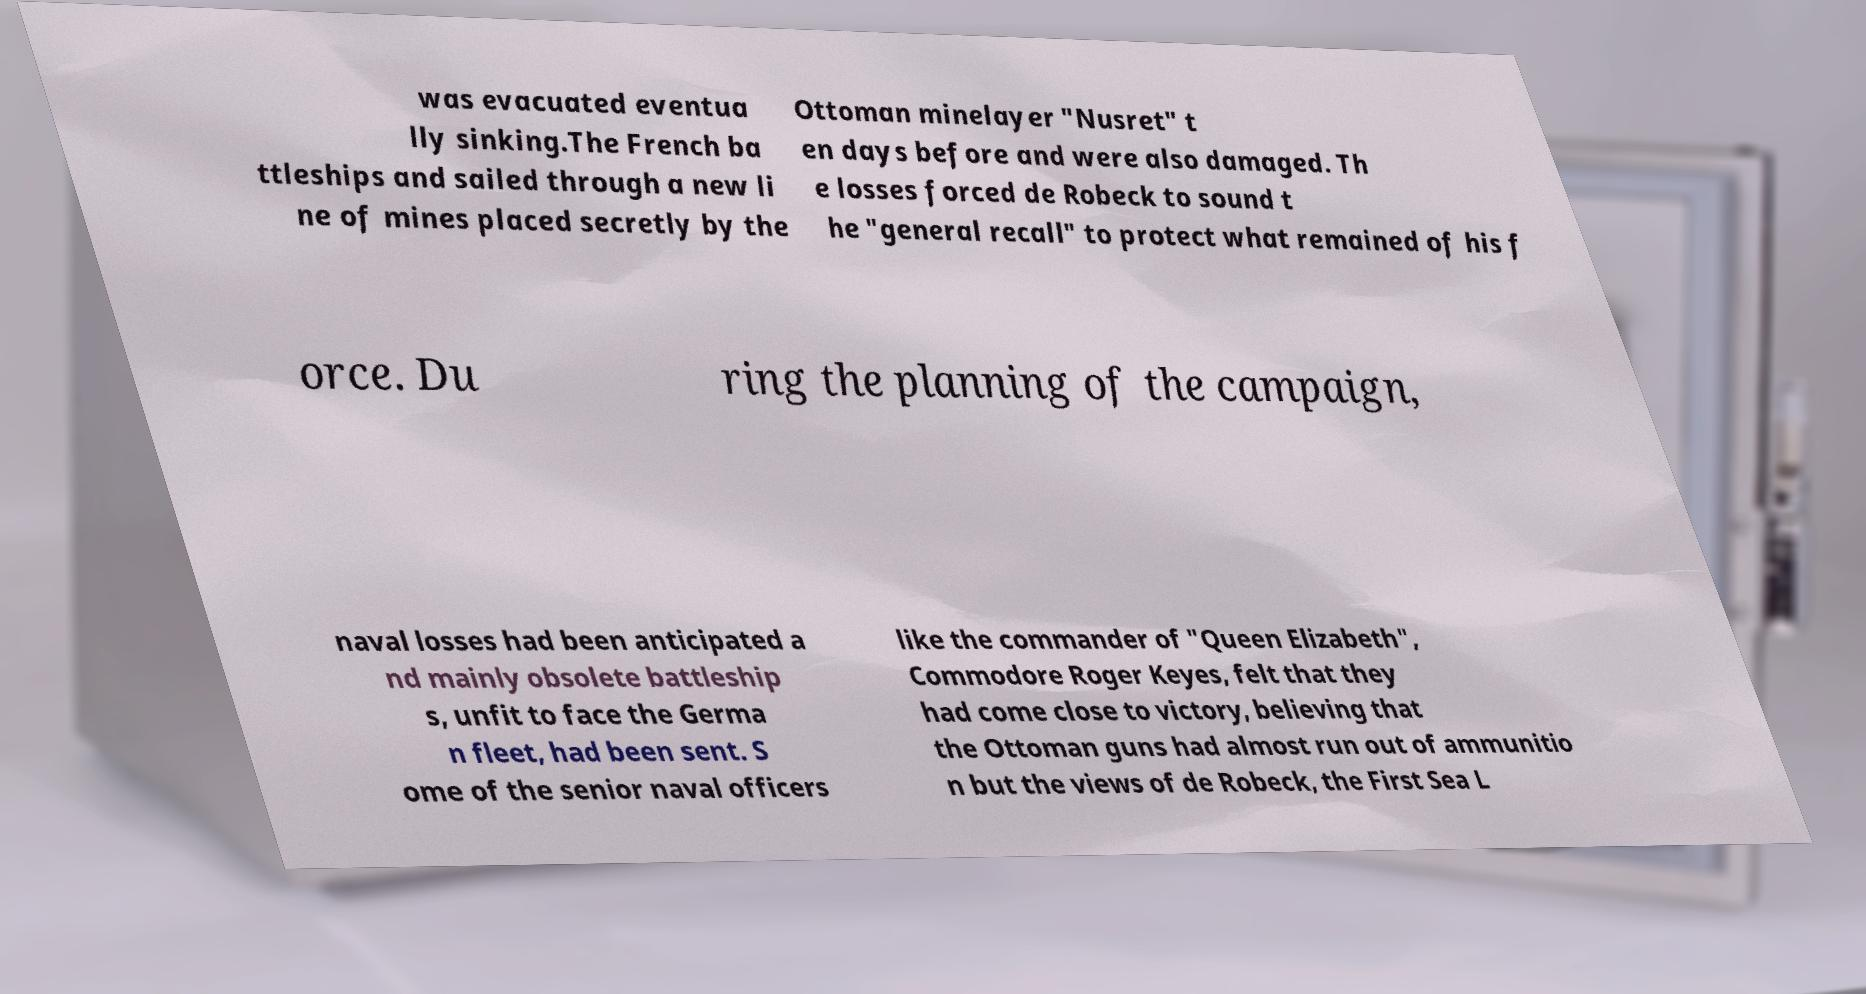Could you assist in decoding the text presented in this image and type it out clearly? was evacuated eventua lly sinking.The French ba ttleships and sailed through a new li ne of mines placed secretly by the Ottoman minelayer "Nusret" t en days before and were also damaged. Th e losses forced de Robeck to sound t he "general recall" to protect what remained of his f orce. Du ring the planning of the campaign, naval losses had been anticipated a nd mainly obsolete battleship s, unfit to face the Germa n fleet, had been sent. S ome of the senior naval officers like the commander of "Queen Elizabeth", Commodore Roger Keyes, felt that they had come close to victory, believing that the Ottoman guns had almost run out of ammunitio n but the views of de Robeck, the First Sea L 